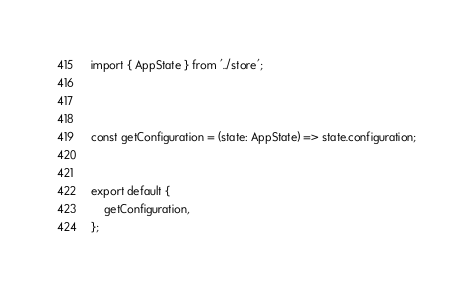<code> <loc_0><loc_0><loc_500><loc_500><_TypeScript_>import { AppState } from '../store';



const getConfiguration = (state: AppState) => state.configuration;


export default {
    getConfiguration,
};
</code> 